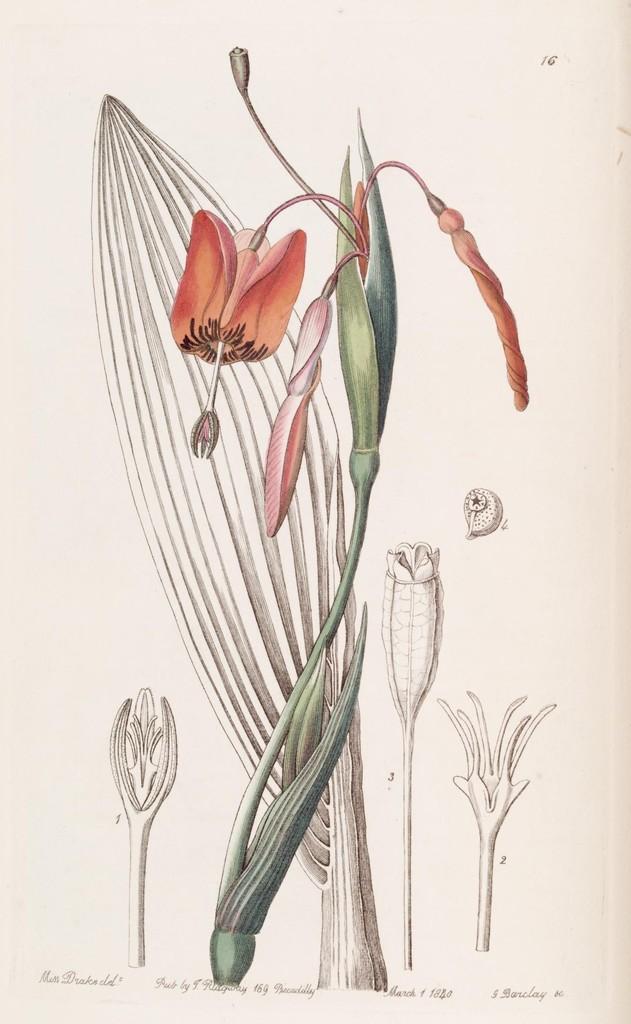How would you summarize this image in a sentence or two? In this image it looks like a paper with tree painting and text on it. 